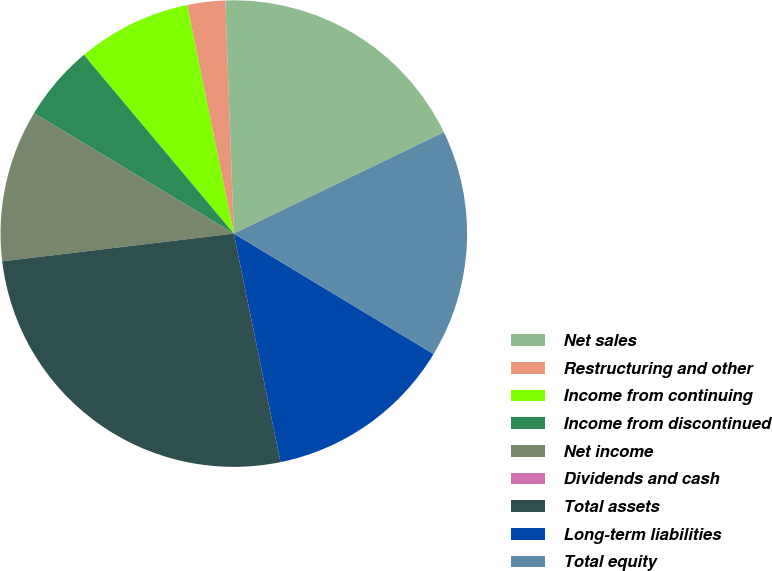Convert chart to OTSL. <chart><loc_0><loc_0><loc_500><loc_500><pie_chart><fcel>Net sales<fcel>Restructuring and other<fcel>Income from continuing<fcel>Income from discontinued<fcel>Net income<fcel>Dividends and cash<fcel>Total assets<fcel>Long-term liabilities<fcel>Total equity<nl><fcel>18.42%<fcel>2.63%<fcel>7.9%<fcel>5.26%<fcel>10.53%<fcel>0.0%<fcel>26.31%<fcel>13.16%<fcel>15.79%<nl></chart> 